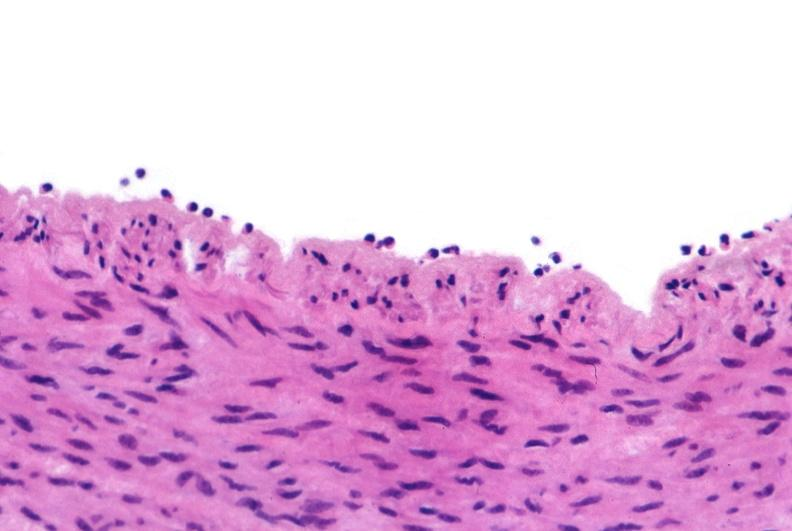s vasculature present?
Answer the question using a single word or phrase. Yes 